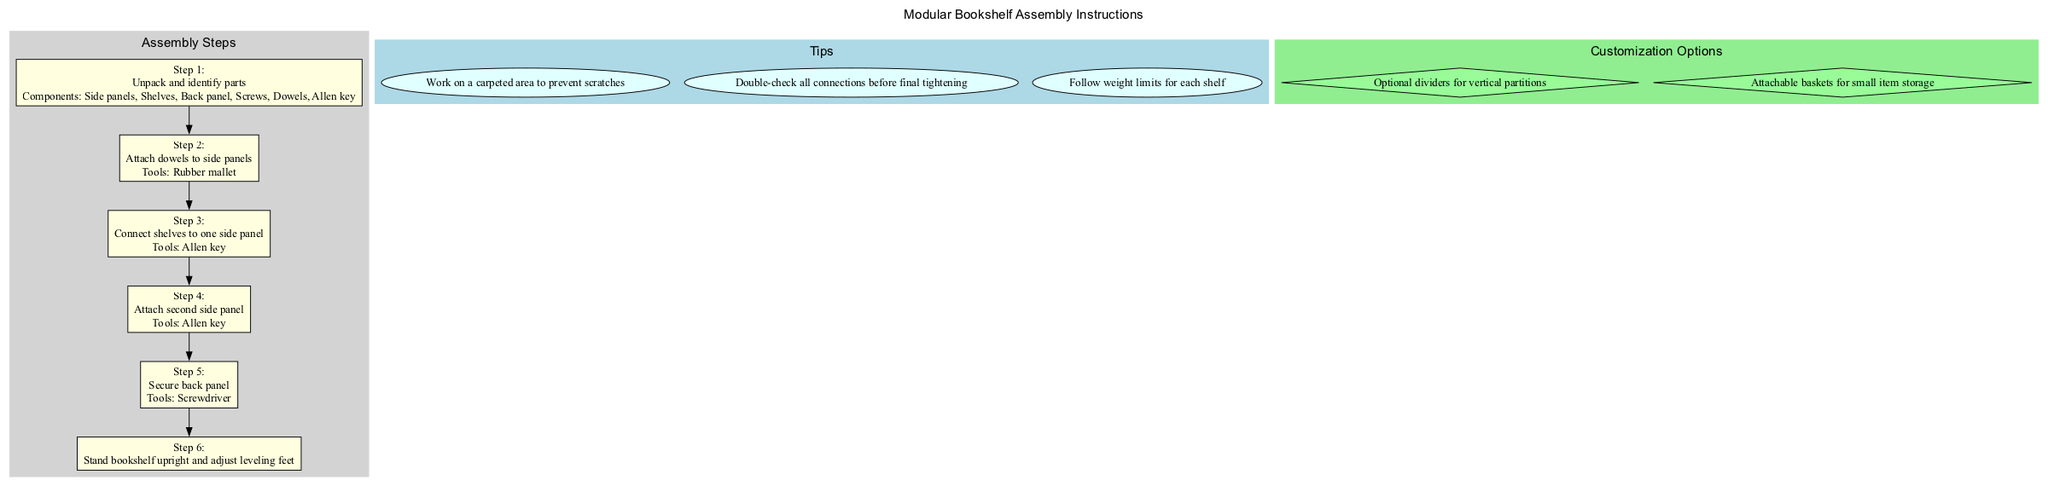What is the first step in the assembly? The first step is "Unpack and identify parts," as listed in the diagram.
Answer: Unpack and identify parts How many main assembly steps are there? By counting the boxes labeled "Step" in the assembly steps section, there are six main steps numbered from 1 to 6.
Answer: 6 Which tool is required for connecting the shelves to one side panel? The tool required for this step, as indicated in the diagram, is the Allen key.
Answer: Allen key What is the last step mentioned in the assembly instructions? The last step is "Stand bookshelf upright and adjust leveling feet," as stated at step 6 in the diagram.
Answer: Stand bookshelf upright and adjust leveling feet What kind of surface should you work on to prevent scratches? The diagram lists in the tips section that you should work on a carpeted area to prevent scratches.
Answer: Carpeted area What are the optional customization options for the bookshelf? The customization options provided in the diagram are "Optional dividers for vertical partitions" and "Attachable baskets for small item storage."
Answer: Optional dividers, Attachable baskets What is the tool used to secure the back panel? According to the diagram, a screwdriver is needed to secure the back panel during assembly.
Answer: Screwdriver What should you do before final tightening of the connections? The corresponding tip suggests that you should double-check all connections before final tightening.
Answer: Double-check all connections 